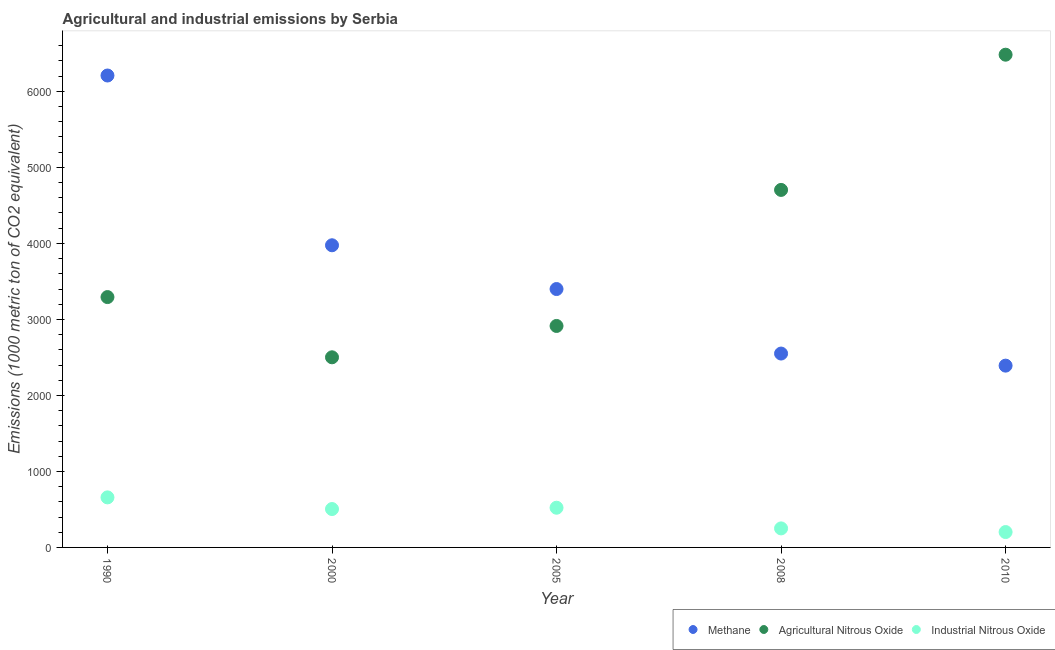Is the number of dotlines equal to the number of legend labels?
Your response must be concise. Yes. What is the amount of agricultural nitrous oxide emissions in 2005?
Ensure brevity in your answer.  2913.8. Across all years, what is the maximum amount of industrial nitrous oxide emissions?
Your response must be concise. 658.4. Across all years, what is the minimum amount of methane emissions?
Offer a terse response. 2391.7. What is the total amount of methane emissions in the graph?
Provide a short and direct response. 1.85e+04. What is the difference between the amount of agricultural nitrous oxide emissions in 2000 and that in 2008?
Make the answer very short. -2202.2. What is the difference between the amount of agricultural nitrous oxide emissions in 2000 and the amount of industrial nitrous oxide emissions in 2008?
Keep it short and to the point. 2251.1. What is the average amount of industrial nitrous oxide emissions per year?
Provide a short and direct response. 427.66. In the year 2005, what is the difference between the amount of agricultural nitrous oxide emissions and amount of industrial nitrous oxide emissions?
Offer a very short reply. 2391.5. What is the ratio of the amount of industrial nitrous oxide emissions in 2000 to that in 2005?
Your response must be concise. 0.97. What is the difference between the highest and the second highest amount of methane emissions?
Provide a succinct answer. 2233.5. What is the difference between the highest and the lowest amount of industrial nitrous oxide emissions?
Ensure brevity in your answer.  456.1. In how many years, is the amount of industrial nitrous oxide emissions greater than the average amount of industrial nitrous oxide emissions taken over all years?
Provide a succinct answer. 3. Is the amount of methane emissions strictly less than the amount of agricultural nitrous oxide emissions over the years?
Offer a terse response. No. How many dotlines are there?
Provide a short and direct response. 3. What is the difference between two consecutive major ticks on the Y-axis?
Keep it short and to the point. 1000. Are the values on the major ticks of Y-axis written in scientific E-notation?
Your response must be concise. No. Does the graph contain any zero values?
Provide a succinct answer. No. Does the graph contain grids?
Your response must be concise. No. Where does the legend appear in the graph?
Make the answer very short. Bottom right. How many legend labels are there?
Give a very brief answer. 3. What is the title of the graph?
Your answer should be compact. Agricultural and industrial emissions by Serbia. Does "Self-employed" appear as one of the legend labels in the graph?
Offer a terse response. No. What is the label or title of the Y-axis?
Give a very brief answer. Emissions (1000 metric ton of CO2 equivalent). What is the Emissions (1000 metric ton of CO2 equivalent) in Methane in 1990?
Make the answer very short. 6208.8. What is the Emissions (1000 metric ton of CO2 equivalent) in Agricultural Nitrous Oxide in 1990?
Provide a succinct answer. 3293.8. What is the Emissions (1000 metric ton of CO2 equivalent) in Industrial Nitrous Oxide in 1990?
Offer a very short reply. 658.4. What is the Emissions (1000 metric ton of CO2 equivalent) of Methane in 2000?
Your response must be concise. 3975.3. What is the Emissions (1000 metric ton of CO2 equivalent) in Agricultural Nitrous Oxide in 2000?
Your answer should be very brief. 2501.4. What is the Emissions (1000 metric ton of CO2 equivalent) in Industrial Nitrous Oxide in 2000?
Offer a terse response. 505. What is the Emissions (1000 metric ton of CO2 equivalent) in Methane in 2005?
Make the answer very short. 3399.6. What is the Emissions (1000 metric ton of CO2 equivalent) in Agricultural Nitrous Oxide in 2005?
Provide a short and direct response. 2913.8. What is the Emissions (1000 metric ton of CO2 equivalent) in Industrial Nitrous Oxide in 2005?
Make the answer very short. 522.3. What is the Emissions (1000 metric ton of CO2 equivalent) in Methane in 2008?
Make the answer very short. 2550.7. What is the Emissions (1000 metric ton of CO2 equivalent) in Agricultural Nitrous Oxide in 2008?
Offer a terse response. 4703.6. What is the Emissions (1000 metric ton of CO2 equivalent) of Industrial Nitrous Oxide in 2008?
Your answer should be very brief. 250.3. What is the Emissions (1000 metric ton of CO2 equivalent) in Methane in 2010?
Provide a short and direct response. 2391.7. What is the Emissions (1000 metric ton of CO2 equivalent) of Agricultural Nitrous Oxide in 2010?
Your response must be concise. 6482.7. What is the Emissions (1000 metric ton of CO2 equivalent) in Industrial Nitrous Oxide in 2010?
Provide a short and direct response. 202.3. Across all years, what is the maximum Emissions (1000 metric ton of CO2 equivalent) of Methane?
Provide a succinct answer. 6208.8. Across all years, what is the maximum Emissions (1000 metric ton of CO2 equivalent) of Agricultural Nitrous Oxide?
Your answer should be very brief. 6482.7. Across all years, what is the maximum Emissions (1000 metric ton of CO2 equivalent) in Industrial Nitrous Oxide?
Your response must be concise. 658.4. Across all years, what is the minimum Emissions (1000 metric ton of CO2 equivalent) in Methane?
Offer a terse response. 2391.7. Across all years, what is the minimum Emissions (1000 metric ton of CO2 equivalent) of Agricultural Nitrous Oxide?
Provide a succinct answer. 2501.4. Across all years, what is the minimum Emissions (1000 metric ton of CO2 equivalent) of Industrial Nitrous Oxide?
Provide a succinct answer. 202.3. What is the total Emissions (1000 metric ton of CO2 equivalent) in Methane in the graph?
Ensure brevity in your answer.  1.85e+04. What is the total Emissions (1000 metric ton of CO2 equivalent) in Agricultural Nitrous Oxide in the graph?
Provide a short and direct response. 1.99e+04. What is the total Emissions (1000 metric ton of CO2 equivalent) in Industrial Nitrous Oxide in the graph?
Offer a very short reply. 2138.3. What is the difference between the Emissions (1000 metric ton of CO2 equivalent) in Methane in 1990 and that in 2000?
Make the answer very short. 2233.5. What is the difference between the Emissions (1000 metric ton of CO2 equivalent) in Agricultural Nitrous Oxide in 1990 and that in 2000?
Offer a very short reply. 792.4. What is the difference between the Emissions (1000 metric ton of CO2 equivalent) of Industrial Nitrous Oxide in 1990 and that in 2000?
Ensure brevity in your answer.  153.4. What is the difference between the Emissions (1000 metric ton of CO2 equivalent) of Methane in 1990 and that in 2005?
Offer a very short reply. 2809.2. What is the difference between the Emissions (1000 metric ton of CO2 equivalent) in Agricultural Nitrous Oxide in 1990 and that in 2005?
Give a very brief answer. 380. What is the difference between the Emissions (1000 metric ton of CO2 equivalent) of Industrial Nitrous Oxide in 1990 and that in 2005?
Your response must be concise. 136.1. What is the difference between the Emissions (1000 metric ton of CO2 equivalent) in Methane in 1990 and that in 2008?
Offer a terse response. 3658.1. What is the difference between the Emissions (1000 metric ton of CO2 equivalent) in Agricultural Nitrous Oxide in 1990 and that in 2008?
Ensure brevity in your answer.  -1409.8. What is the difference between the Emissions (1000 metric ton of CO2 equivalent) in Industrial Nitrous Oxide in 1990 and that in 2008?
Provide a short and direct response. 408.1. What is the difference between the Emissions (1000 metric ton of CO2 equivalent) in Methane in 1990 and that in 2010?
Provide a short and direct response. 3817.1. What is the difference between the Emissions (1000 metric ton of CO2 equivalent) in Agricultural Nitrous Oxide in 1990 and that in 2010?
Offer a very short reply. -3188.9. What is the difference between the Emissions (1000 metric ton of CO2 equivalent) of Industrial Nitrous Oxide in 1990 and that in 2010?
Your response must be concise. 456.1. What is the difference between the Emissions (1000 metric ton of CO2 equivalent) in Methane in 2000 and that in 2005?
Your answer should be very brief. 575.7. What is the difference between the Emissions (1000 metric ton of CO2 equivalent) of Agricultural Nitrous Oxide in 2000 and that in 2005?
Provide a short and direct response. -412.4. What is the difference between the Emissions (1000 metric ton of CO2 equivalent) of Industrial Nitrous Oxide in 2000 and that in 2005?
Your response must be concise. -17.3. What is the difference between the Emissions (1000 metric ton of CO2 equivalent) of Methane in 2000 and that in 2008?
Your answer should be compact. 1424.6. What is the difference between the Emissions (1000 metric ton of CO2 equivalent) in Agricultural Nitrous Oxide in 2000 and that in 2008?
Your answer should be compact. -2202.2. What is the difference between the Emissions (1000 metric ton of CO2 equivalent) of Industrial Nitrous Oxide in 2000 and that in 2008?
Your answer should be very brief. 254.7. What is the difference between the Emissions (1000 metric ton of CO2 equivalent) of Methane in 2000 and that in 2010?
Ensure brevity in your answer.  1583.6. What is the difference between the Emissions (1000 metric ton of CO2 equivalent) of Agricultural Nitrous Oxide in 2000 and that in 2010?
Make the answer very short. -3981.3. What is the difference between the Emissions (1000 metric ton of CO2 equivalent) in Industrial Nitrous Oxide in 2000 and that in 2010?
Give a very brief answer. 302.7. What is the difference between the Emissions (1000 metric ton of CO2 equivalent) of Methane in 2005 and that in 2008?
Provide a succinct answer. 848.9. What is the difference between the Emissions (1000 metric ton of CO2 equivalent) of Agricultural Nitrous Oxide in 2005 and that in 2008?
Ensure brevity in your answer.  -1789.8. What is the difference between the Emissions (1000 metric ton of CO2 equivalent) of Industrial Nitrous Oxide in 2005 and that in 2008?
Ensure brevity in your answer.  272. What is the difference between the Emissions (1000 metric ton of CO2 equivalent) in Methane in 2005 and that in 2010?
Make the answer very short. 1007.9. What is the difference between the Emissions (1000 metric ton of CO2 equivalent) in Agricultural Nitrous Oxide in 2005 and that in 2010?
Give a very brief answer. -3568.9. What is the difference between the Emissions (1000 metric ton of CO2 equivalent) in Industrial Nitrous Oxide in 2005 and that in 2010?
Provide a short and direct response. 320. What is the difference between the Emissions (1000 metric ton of CO2 equivalent) in Methane in 2008 and that in 2010?
Make the answer very short. 159. What is the difference between the Emissions (1000 metric ton of CO2 equivalent) of Agricultural Nitrous Oxide in 2008 and that in 2010?
Provide a succinct answer. -1779.1. What is the difference between the Emissions (1000 metric ton of CO2 equivalent) in Industrial Nitrous Oxide in 2008 and that in 2010?
Ensure brevity in your answer.  48. What is the difference between the Emissions (1000 metric ton of CO2 equivalent) of Methane in 1990 and the Emissions (1000 metric ton of CO2 equivalent) of Agricultural Nitrous Oxide in 2000?
Give a very brief answer. 3707.4. What is the difference between the Emissions (1000 metric ton of CO2 equivalent) of Methane in 1990 and the Emissions (1000 metric ton of CO2 equivalent) of Industrial Nitrous Oxide in 2000?
Provide a succinct answer. 5703.8. What is the difference between the Emissions (1000 metric ton of CO2 equivalent) of Agricultural Nitrous Oxide in 1990 and the Emissions (1000 metric ton of CO2 equivalent) of Industrial Nitrous Oxide in 2000?
Offer a terse response. 2788.8. What is the difference between the Emissions (1000 metric ton of CO2 equivalent) in Methane in 1990 and the Emissions (1000 metric ton of CO2 equivalent) in Agricultural Nitrous Oxide in 2005?
Provide a succinct answer. 3295. What is the difference between the Emissions (1000 metric ton of CO2 equivalent) in Methane in 1990 and the Emissions (1000 metric ton of CO2 equivalent) in Industrial Nitrous Oxide in 2005?
Provide a succinct answer. 5686.5. What is the difference between the Emissions (1000 metric ton of CO2 equivalent) in Agricultural Nitrous Oxide in 1990 and the Emissions (1000 metric ton of CO2 equivalent) in Industrial Nitrous Oxide in 2005?
Your response must be concise. 2771.5. What is the difference between the Emissions (1000 metric ton of CO2 equivalent) of Methane in 1990 and the Emissions (1000 metric ton of CO2 equivalent) of Agricultural Nitrous Oxide in 2008?
Your answer should be very brief. 1505.2. What is the difference between the Emissions (1000 metric ton of CO2 equivalent) of Methane in 1990 and the Emissions (1000 metric ton of CO2 equivalent) of Industrial Nitrous Oxide in 2008?
Ensure brevity in your answer.  5958.5. What is the difference between the Emissions (1000 metric ton of CO2 equivalent) of Agricultural Nitrous Oxide in 1990 and the Emissions (1000 metric ton of CO2 equivalent) of Industrial Nitrous Oxide in 2008?
Give a very brief answer. 3043.5. What is the difference between the Emissions (1000 metric ton of CO2 equivalent) of Methane in 1990 and the Emissions (1000 metric ton of CO2 equivalent) of Agricultural Nitrous Oxide in 2010?
Your answer should be compact. -273.9. What is the difference between the Emissions (1000 metric ton of CO2 equivalent) of Methane in 1990 and the Emissions (1000 metric ton of CO2 equivalent) of Industrial Nitrous Oxide in 2010?
Your answer should be very brief. 6006.5. What is the difference between the Emissions (1000 metric ton of CO2 equivalent) in Agricultural Nitrous Oxide in 1990 and the Emissions (1000 metric ton of CO2 equivalent) in Industrial Nitrous Oxide in 2010?
Your answer should be very brief. 3091.5. What is the difference between the Emissions (1000 metric ton of CO2 equivalent) of Methane in 2000 and the Emissions (1000 metric ton of CO2 equivalent) of Agricultural Nitrous Oxide in 2005?
Provide a short and direct response. 1061.5. What is the difference between the Emissions (1000 metric ton of CO2 equivalent) of Methane in 2000 and the Emissions (1000 metric ton of CO2 equivalent) of Industrial Nitrous Oxide in 2005?
Offer a very short reply. 3453. What is the difference between the Emissions (1000 metric ton of CO2 equivalent) in Agricultural Nitrous Oxide in 2000 and the Emissions (1000 metric ton of CO2 equivalent) in Industrial Nitrous Oxide in 2005?
Your answer should be very brief. 1979.1. What is the difference between the Emissions (1000 metric ton of CO2 equivalent) of Methane in 2000 and the Emissions (1000 metric ton of CO2 equivalent) of Agricultural Nitrous Oxide in 2008?
Your answer should be compact. -728.3. What is the difference between the Emissions (1000 metric ton of CO2 equivalent) in Methane in 2000 and the Emissions (1000 metric ton of CO2 equivalent) in Industrial Nitrous Oxide in 2008?
Your answer should be compact. 3725. What is the difference between the Emissions (1000 metric ton of CO2 equivalent) of Agricultural Nitrous Oxide in 2000 and the Emissions (1000 metric ton of CO2 equivalent) of Industrial Nitrous Oxide in 2008?
Provide a short and direct response. 2251.1. What is the difference between the Emissions (1000 metric ton of CO2 equivalent) in Methane in 2000 and the Emissions (1000 metric ton of CO2 equivalent) in Agricultural Nitrous Oxide in 2010?
Your response must be concise. -2507.4. What is the difference between the Emissions (1000 metric ton of CO2 equivalent) of Methane in 2000 and the Emissions (1000 metric ton of CO2 equivalent) of Industrial Nitrous Oxide in 2010?
Make the answer very short. 3773. What is the difference between the Emissions (1000 metric ton of CO2 equivalent) of Agricultural Nitrous Oxide in 2000 and the Emissions (1000 metric ton of CO2 equivalent) of Industrial Nitrous Oxide in 2010?
Offer a terse response. 2299.1. What is the difference between the Emissions (1000 metric ton of CO2 equivalent) of Methane in 2005 and the Emissions (1000 metric ton of CO2 equivalent) of Agricultural Nitrous Oxide in 2008?
Give a very brief answer. -1304. What is the difference between the Emissions (1000 metric ton of CO2 equivalent) of Methane in 2005 and the Emissions (1000 metric ton of CO2 equivalent) of Industrial Nitrous Oxide in 2008?
Provide a short and direct response. 3149.3. What is the difference between the Emissions (1000 metric ton of CO2 equivalent) in Agricultural Nitrous Oxide in 2005 and the Emissions (1000 metric ton of CO2 equivalent) in Industrial Nitrous Oxide in 2008?
Provide a succinct answer. 2663.5. What is the difference between the Emissions (1000 metric ton of CO2 equivalent) of Methane in 2005 and the Emissions (1000 metric ton of CO2 equivalent) of Agricultural Nitrous Oxide in 2010?
Offer a very short reply. -3083.1. What is the difference between the Emissions (1000 metric ton of CO2 equivalent) of Methane in 2005 and the Emissions (1000 metric ton of CO2 equivalent) of Industrial Nitrous Oxide in 2010?
Make the answer very short. 3197.3. What is the difference between the Emissions (1000 metric ton of CO2 equivalent) of Agricultural Nitrous Oxide in 2005 and the Emissions (1000 metric ton of CO2 equivalent) of Industrial Nitrous Oxide in 2010?
Your response must be concise. 2711.5. What is the difference between the Emissions (1000 metric ton of CO2 equivalent) of Methane in 2008 and the Emissions (1000 metric ton of CO2 equivalent) of Agricultural Nitrous Oxide in 2010?
Make the answer very short. -3932. What is the difference between the Emissions (1000 metric ton of CO2 equivalent) of Methane in 2008 and the Emissions (1000 metric ton of CO2 equivalent) of Industrial Nitrous Oxide in 2010?
Keep it short and to the point. 2348.4. What is the difference between the Emissions (1000 metric ton of CO2 equivalent) in Agricultural Nitrous Oxide in 2008 and the Emissions (1000 metric ton of CO2 equivalent) in Industrial Nitrous Oxide in 2010?
Give a very brief answer. 4501.3. What is the average Emissions (1000 metric ton of CO2 equivalent) in Methane per year?
Make the answer very short. 3705.22. What is the average Emissions (1000 metric ton of CO2 equivalent) of Agricultural Nitrous Oxide per year?
Offer a very short reply. 3979.06. What is the average Emissions (1000 metric ton of CO2 equivalent) in Industrial Nitrous Oxide per year?
Your answer should be very brief. 427.66. In the year 1990, what is the difference between the Emissions (1000 metric ton of CO2 equivalent) of Methane and Emissions (1000 metric ton of CO2 equivalent) of Agricultural Nitrous Oxide?
Give a very brief answer. 2915. In the year 1990, what is the difference between the Emissions (1000 metric ton of CO2 equivalent) in Methane and Emissions (1000 metric ton of CO2 equivalent) in Industrial Nitrous Oxide?
Provide a short and direct response. 5550.4. In the year 1990, what is the difference between the Emissions (1000 metric ton of CO2 equivalent) of Agricultural Nitrous Oxide and Emissions (1000 metric ton of CO2 equivalent) of Industrial Nitrous Oxide?
Your response must be concise. 2635.4. In the year 2000, what is the difference between the Emissions (1000 metric ton of CO2 equivalent) of Methane and Emissions (1000 metric ton of CO2 equivalent) of Agricultural Nitrous Oxide?
Keep it short and to the point. 1473.9. In the year 2000, what is the difference between the Emissions (1000 metric ton of CO2 equivalent) of Methane and Emissions (1000 metric ton of CO2 equivalent) of Industrial Nitrous Oxide?
Make the answer very short. 3470.3. In the year 2000, what is the difference between the Emissions (1000 metric ton of CO2 equivalent) of Agricultural Nitrous Oxide and Emissions (1000 metric ton of CO2 equivalent) of Industrial Nitrous Oxide?
Offer a very short reply. 1996.4. In the year 2005, what is the difference between the Emissions (1000 metric ton of CO2 equivalent) of Methane and Emissions (1000 metric ton of CO2 equivalent) of Agricultural Nitrous Oxide?
Offer a terse response. 485.8. In the year 2005, what is the difference between the Emissions (1000 metric ton of CO2 equivalent) of Methane and Emissions (1000 metric ton of CO2 equivalent) of Industrial Nitrous Oxide?
Ensure brevity in your answer.  2877.3. In the year 2005, what is the difference between the Emissions (1000 metric ton of CO2 equivalent) of Agricultural Nitrous Oxide and Emissions (1000 metric ton of CO2 equivalent) of Industrial Nitrous Oxide?
Make the answer very short. 2391.5. In the year 2008, what is the difference between the Emissions (1000 metric ton of CO2 equivalent) in Methane and Emissions (1000 metric ton of CO2 equivalent) in Agricultural Nitrous Oxide?
Give a very brief answer. -2152.9. In the year 2008, what is the difference between the Emissions (1000 metric ton of CO2 equivalent) in Methane and Emissions (1000 metric ton of CO2 equivalent) in Industrial Nitrous Oxide?
Offer a terse response. 2300.4. In the year 2008, what is the difference between the Emissions (1000 metric ton of CO2 equivalent) in Agricultural Nitrous Oxide and Emissions (1000 metric ton of CO2 equivalent) in Industrial Nitrous Oxide?
Keep it short and to the point. 4453.3. In the year 2010, what is the difference between the Emissions (1000 metric ton of CO2 equivalent) in Methane and Emissions (1000 metric ton of CO2 equivalent) in Agricultural Nitrous Oxide?
Ensure brevity in your answer.  -4091. In the year 2010, what is the difference between the Emissions (1000 metric ton of CO2 equivalent) in Methane and Emissions (1000 metric ton of CO2 equivalent) in Industrial Nitrous Oxide?
Ensure brevity in your answer.  2189.4. In the year 2010, what is the difference between the Emissions (1000 metric ton of CO2 equivalent) of Agricultural Nitrous Oxide and Emissions (1000 metric ton of CO2 equivalent) of Industrial Nitrous Oxide?
Offer a terse response. 6280.4. What is the ratio of the Emissions (1000 metric ton of CO2 equivalent) of Methane in 1990 to that in 2000?
Your response must be concise. 1.56. What is the ratio of the Emissions (1000 metric ton of CO2 equivalent) of Agricultural Nitrous Oxide in 1990 to that in 2000?
Make the answer very short. 1.32. What is the ratio of the Emissions (1000 metric ton of CO2 equivalent) in Industrial Nitrous Oxide in 1990 to that in 2000?
Offer a terse response. 1.3. What is the ratio of the Emissions (1000 metric ton of CO2 equivalent) in Methane in 1990 to that in 2005?
Offer a very short reply. 1.83. What is the ratio of the Emissions (1000 metric ton of CO2 equivalent) of Agricultural Nitrous Oxide in 1990 to that in 2005?
Make the answer very short. 1.13. What is the ratio of the Emissions (1000 metric ton of CO2 equivalent) in Industrial Nitrous Oxide in 1990 to that in 2005?
Provide a short and direct response. 1.26. What is the ratio of the Emissions (1000 metric ton of CO2 equivalent) in Methane in 1990 to that in 2008?
Make the answer very short. 2.43. What is the ratio of the Emissions (1000 metric ton of CO2 equivalent) of Agricultural Nitrous Oxide in 1990 to that in 2008?
Make the answer very short. 0.7. What is the ratio of the Emissions (1000 metric ton of CO2 equivalent) in Industrial Nitrous Oxide in 1990 to that in 2008?
Your answer should be compact. 2.63. What is the ratio of the Emissions (1000 metric ton of CO2 equivalent) in Methane in 1990 to that in 2010?
Offer a terse response. 2.6. What is the ratio of the Emissions (1000 metric ton of CO2 equivalent) in Agricultural Nitrous Oxide in 1990 to that in 2010?
Make the answer very short. 0.51. What is the ratio of the Emissions (1000 metric ton of CO2 equivalent) in Industrial Nitrous Oxide in 1990 to that in 2010?
Offer a terse response. 3.25. What is the ratio of the Emissions (1000 metric ton of CO2 equivalent) in Methane in 2000 to that in 2005?
Provide a succinct answer. 1.17. What is the ratio of the Emissions (1000 metric ton of CO2 equivalent) of Agricultural Nitrous Oxide in 2000 to that in 2005?
Keep it short and to the point. 0.86. What is the ratio of the Emissions (1000 metric ton of CO2 equivalent) in Industrial Nitrous Oxide in 2000 to that in 2005?
Your answer should be very brief. 0.97. What is the ratio of the Emissions (1000 metric ton of CO2 equivalent) in Methane in 2000 to that in 2008?
Ensure brevity in your answer.  1.56. What is the ratio of the Emissions (1000 metric ton of CO2 equivalent) in Agricultural Nitrous Oxide in 2000 to that in 2008?
Your answer should be very brief. 0.53. What is the ratio of the Emissions (1000 metric ton of CO2 equivalent) in Industrial Nitrous Oxide in 2000 to that in 2008?
Ensure brevity in your answer.  2.02. What is the ratio of the Emissions (1000 metric ton of CO2 equivalent) in Methane in 2000 to that in 2010?
Ensure brevity in your answer.  1.66. What is the ratio of the Emissions (1000 metric ton of CO2 equivalent) in Agricultural Nitrous Oxide in 2000 to that in 2010?
Give a very brief answer. 0.39. What is the ratio of the Emissions (1000 metric ton of CO2 equivalent) in Industrial Nitrous Oxide in 2000 to that in 2010?
Your answer should be very brief. 2.5. What is the ratio of the Emissions (1000 metric ton of CO2 equivalent) in Methane in 2005 to that in 2008?
Make the answer very short. 1.33. What is the ratio of the Emissions (1000 metric ton of CO2 equivalent) in Agricultural Nitrous Oxide in 2005 to that in 2008?
Ensure brevity in your answer.  0.62. What is the ratio of the Emissions (1000 metric ton of CO2 equivalent) in Industrial Nitrous Oxide in 2005 to that in 2008?
Provide a succinct answer. 2.09. What is the ratio of the Emissions (1000 metric ton of CO2 equivalent) of Methane in 2005 to that in 2010?
Offer a terse response. 1.42. What is the ratio of the Emissions (1000 metric ton of CO2 equivalent) in Agricultural Nitrous Oxide in 2005 to that in 2010?
Keep it short and to the point. 0.45. What is the ratio of the Emissions (1000 metric ton of CO2 equivalent) in Industrial Nitrous Oxide in 2005 to that in 2010?
Give a very brief answer. 2.58. What is the ratio of the Emissions (1000 metric ton of CO2 equivalent) of Methane in 2008 to that in 2010?
Offer a terse response. 1.07. What is the ratio of the Emissions (1000 metric ton of CO2 equivalent) in Agricultural Nitrous Oxide in 2008 to that in 2010?
Give a very brief answer. 0.73. What is the ratio of the Emissions (1000 metric ton of CO2 equivalent) in Industrial Nitrous Oxide in 2008 to that in 2010?
Offer a very short reply. 1.24. What is the difference between the highest and the second highest Emissions (1000 metric ton of CO2 equivalent) in Methane?
Your answer should be compact. 2233.5. What is the difference between the highest and the second highest Emissions (1000 metric ton of CO2 equivalent) in Agricultural Nitrous Oxide?
Offer a terse response. 1779.1. What is the difference between the highest and the second highest Emissions (1000 metric ton of CO2 equivalent) in Industrial Nitrous Oxide?
Provide a succinct answer. 136.1. What is the difference between the highest and the lowest Emissions (1000 metric ton of CO2 equivalent) of Methane?
Provide a succinct answer. 3817.1. What is the difference between the highest and the lowest Emissions (1000 metric ton of CO2 equivalent) of Agricultural Nitrous Oxide?
Your response must be concise. 3981.3. What is the difference between the highest and the lowest Emissions (1000 metric ton of CO2 equivalent) of Industrial Nitrous Oxide?
Your answer should be compact. 456.1. 